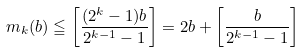Convert formula to latex. <formula><loc_0><loc_0><loc_500><loc_500>m _ { k } ( b ) \leqq \left [ \frac { ( 2 ^ { k } - 1 ) b } { 2 ^ { k - 1 } - 1 } \right ] = 2 b + \left [ \frac { b } { 2 ^ { k - 1 } - 1 } \right ]</formula> 